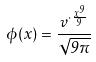Convert formula to latex. <formula><loc_0><loc_0><loc_500><loc_500>\phi ( x ) = \frac { v ^ { \cdot \frac { x ^ { 9 } } { 9 } } } { \sqrt { 9 \pi } }</formula> 